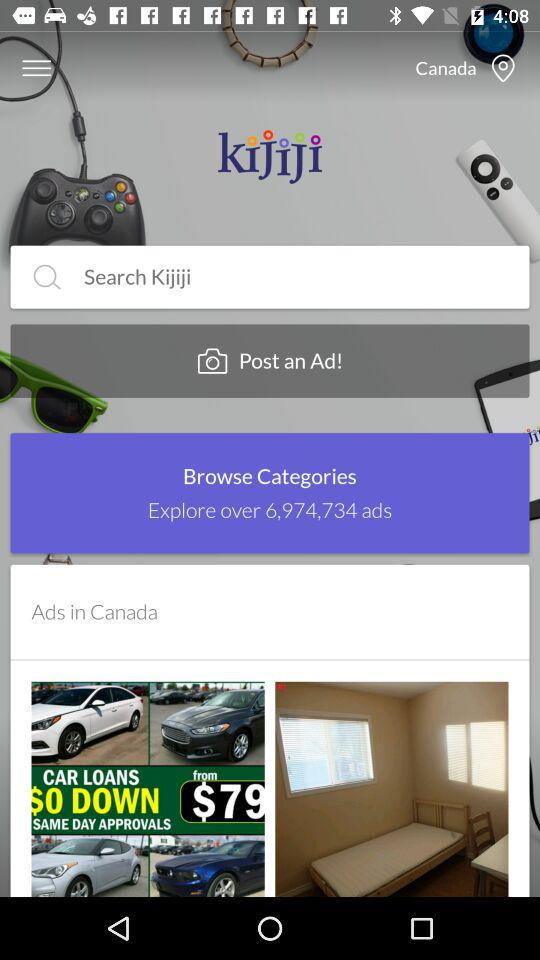Over how many ads can be explored? There are over 6,974,734 ads that can be explored. 